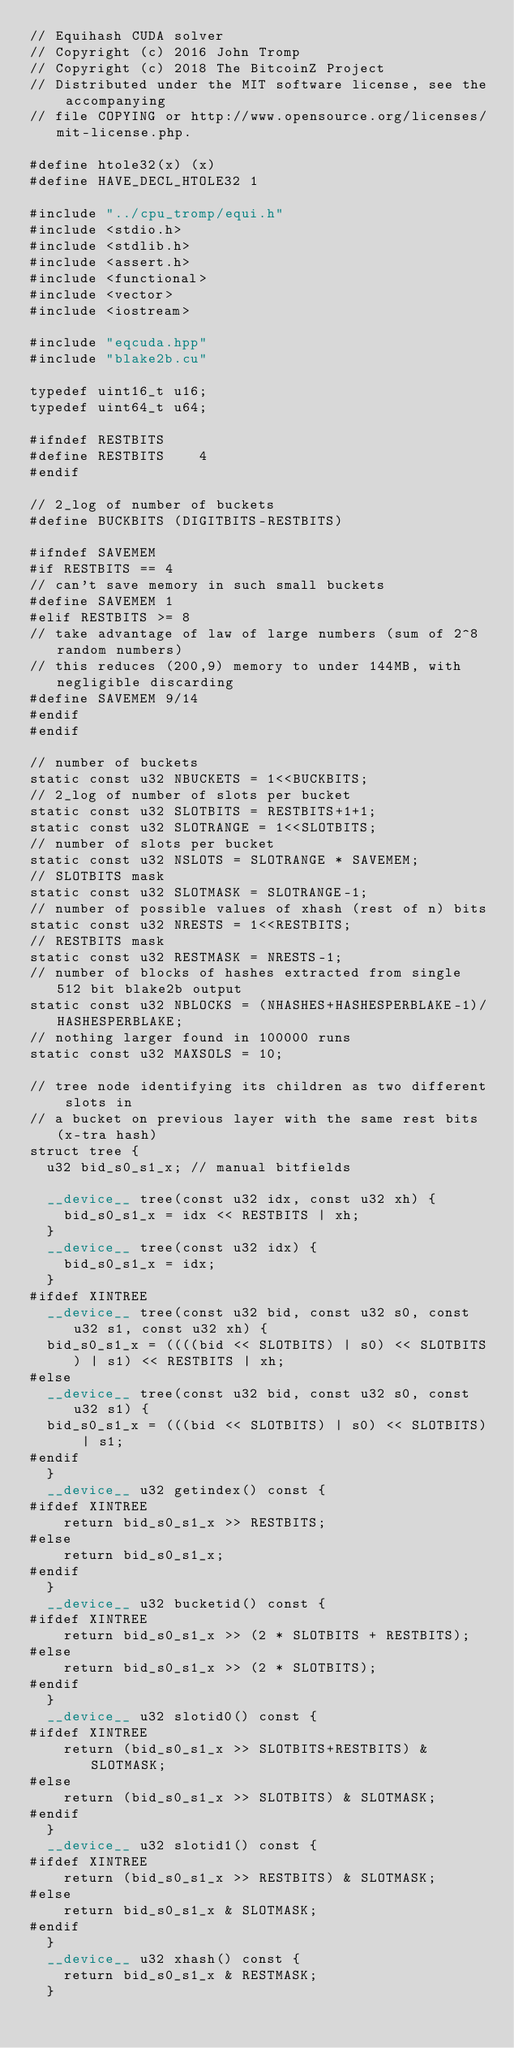<code> <loc_0><loc_0><loc_500><loc_500><_Cuda_>// Equihash CUDA solver
// Copyright (c) 2016 John Tromp
// Copyright (c) 2018 The BitcoinZ Project
// Distributed under the MIT software license, see the accompanying
// file COPYING or http://www.opensource.org/licenses/mit-license.php.

#define htole32(x) (x)
#define HAVE_DECL_HTOLE32 1

#include "../cpu_tromp/equi.h"
#include <stdio.h>
#include <stdlib.h>
#include <assert.h>
#include <functional>
#include <vector>
#include <iostream>

#include "eqcuda.hpp"
#include "blake2b.cu"

typedef uint16_t u16;
typedef uint64_t u64;

#ifndef RESTBITS
#define RESTBITS	4
#endif

// 2_log of number of buckets
#define BUCKBITS (DIGITBITS-RESTBITS)

#ifndef SAVEMEM
#if RESTBITS == 4
// can't save memory in such small buckets
#define SAVEMEM 1
#elif RESTBITS >= 8
// take advantage of law of large numbers (sum of 2^8 random numbers)
// this reduces (200,9) memory to under 144MB, with negligible discarding
#define SAVEMEM 9/14
#endif
#endif

// number of buckets
static const u32 NBUCKETS = 1<<BUCKBITS;
// 2_log of number of slots per bucket
static const u32 SLOTBITS = RESTBITS+1+1;
static const u32 SLOTRANGE = 1<<SLOTBITS;
// number of slots per bucket
static const u32 NSLOTS = SLOTRANGE * SAVEMEM;
// SLOTBITS mask
static const u32 SLOTMASK = SLOTRANGE-1;
// number of possible values of xhash (rest of n) bits
static const u32 NRESTS = 1<<RESTBITS;
// RESTBITS mask
static const u32 RESTMASK = NRESTS-1;
// number of blocks of hashes extracted from single 512 bit blake2b output
static const u32 NBLOCKS = (NHASHES+HASHESPERBLAKE-1)/HASHESPERBLAKE;
// nothing larger found in 100000 runs
static const u32 MAXSOLS = 10;

// tree node identifying its children as two different slots in
// a bucket on previous layer with the same rest bits (x-tra hash)
struct tree {
  u32 bid_s0_s1_x; // manual bitfields

  __device__ tree(const u32 idx, const u32 xh) {
    bid_s0_s1_x = idx << RESTBITS | xh;
  }
  __device__ tree(const u32 idx) {
    bid_s0_s1_x = idx;
  }
#ifdef XINTREE
  __device__ tree(const u32 bid, const u32 s0, const u32 s1, const u32 xh) {
  bid_s0_s1_x = ((((bid << SLOTBITS) | s0) << SLOTBITS) | s1) << RESTBITS | xh;
#else
  __device__ tree(const u32 bid, const u32 s0, const u32 s1) {
  bid_s0_s1_x = (((bid << SLOTBITS) | s0) << SLOTBITS) | s1;
#endif
  }
  __device__ u32 getindex() const {
#ifdef XINTREE
    return bid_s0_s1_x >> RESTBITS;
#else
    return bid_s0_s1_x;
#endif
  }
  __device__ u32 bucketid() const {
#ifdef XINTREE
    return bid_s0_s1_x >> (2 * SLOTBITS + RESTBITS);
#else
    return bid_s0_s1_x >> (2 * SLOTBITS);
#endif
  }
  __device__ u32 slotid0() const {
#ifdef XINTREE
    return (bid_s0_s1_x >> SLOTBITS+RESTBITS) & SLOTMASK;
#else
    return (bid_s0_s1_x >> SLOTBITS) & SLOTMASK;
#endif
  }
  __device__ u32 slotid1() const {
#ifdef XINTREE
    return (bid_s0_s1_x >> RESTBITS) & SLOTMASK;
#else
    return bid_s0_s1_x & SLOTMASK;
#endif
  }
  __device__ u32 xhash() const {
    return bid_s0_s1_x & RESTMASK;
  }</code> 